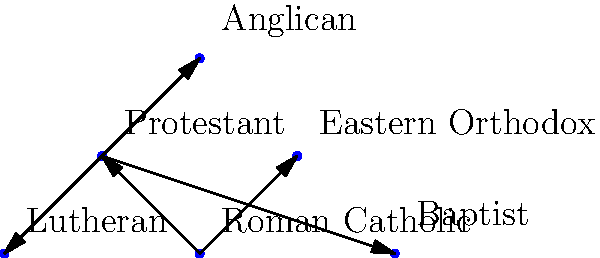Based on the network diagram of Christian denominations, which denomination directly influenced the formation of the Anglican, Lutheran, and Baptist churches? To answer this question, let's analyze the network diagram step-by-step:

1. The diagram shows six major Christian denominations: Roman Catholic, Eastern Orthodox, Protestant, Anglican, Lutheran, and Baptist.

2. The arrows in the diagram represent historical influences or connections between denominations.

3. We can see that the Roman Catholic Church has arrows pointing to both Eastern Orthodox and Protestant denominations, indicating its influence on their formation.

4. The Protestant denomination has arrows pointing to Anglican, Lutheran, and Baptist churches.

5. This means that the Protestant movement directly influenced the formation of these three denominations.

6. The Anglican, Lutheran, and Baptist churches do not have arrows pointing to each other, suggesting they developed independently within the broader Protestant movement.

Therefore, based on this network diagram, the Protestant denomination is the one that directly influenced the formation of the Anglican, Lutheran, and Baptist churches.
Answer: Protestant 